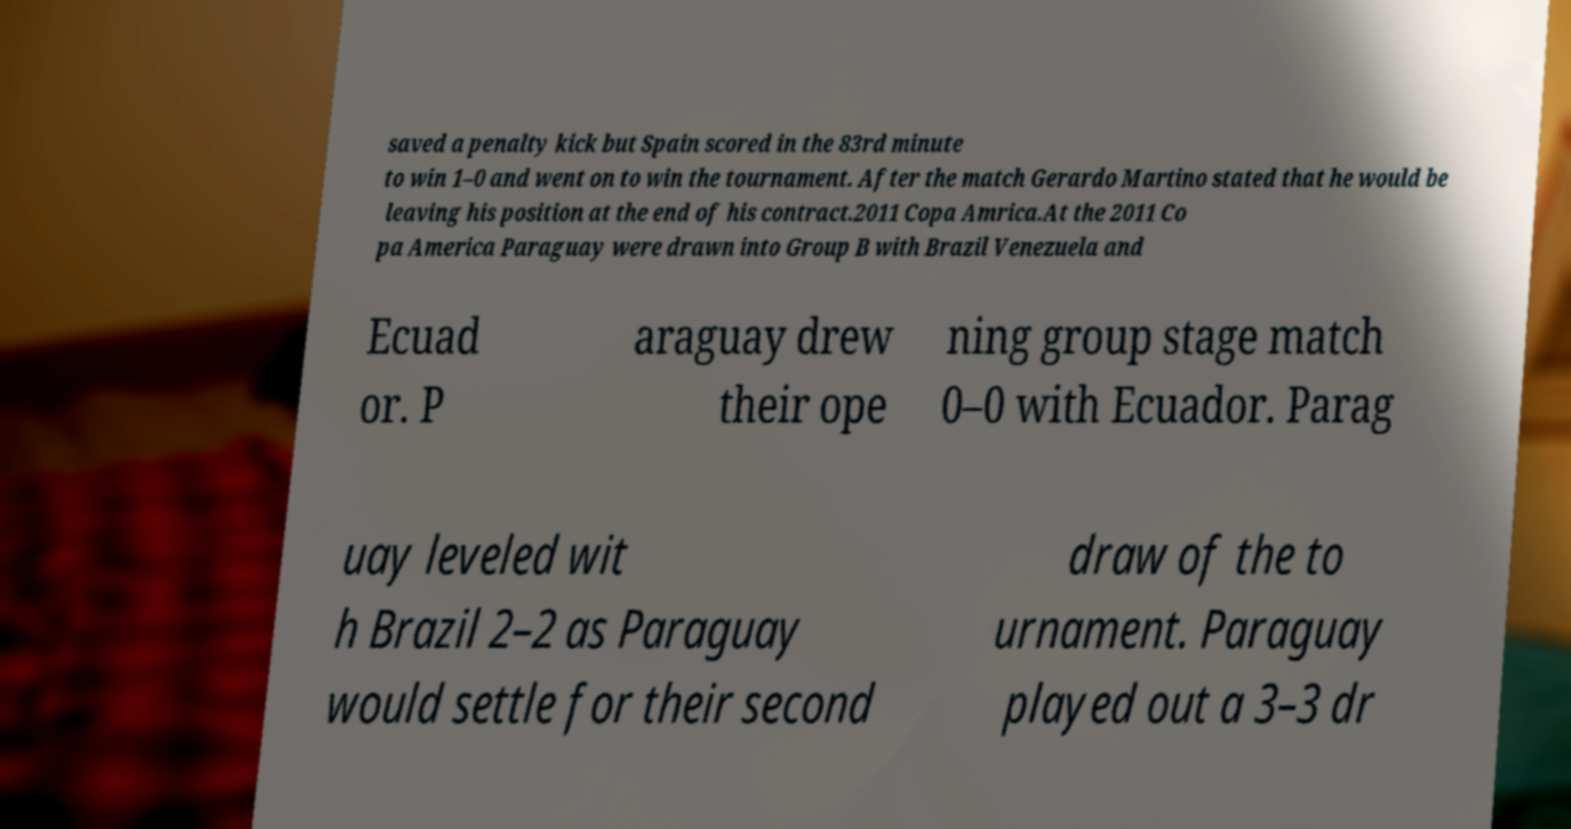Can you accurately transcribe the text from the provided image for me? saved a penalty kick but Spain scored in the 83rd minute to win 1–0 and went on to win the tournament. After the match Gerardo Martino stated that he would be leaving his position at the end of his contract.2011 Copa Amrica.At the 2011 Co pa America Paraguay were drawn into Group B with Brazil Venezuela and Ecuad or. P araguay drew their ope ning group stage match 0–0 with Ecuador. Parag uay leveled wit h Brazil 2–2 as Paraguay would settle for their second draw of the to urnament. Paraguay played out a 3–3 dr 